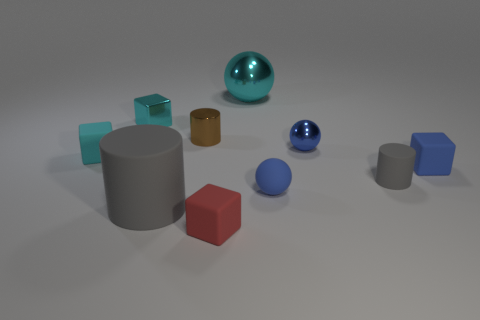Do the tiny metal ball and the rubber ball have the same color?
Keep it short and to the point. Yes. Is there a brown matte thing that has the same shape as the blue metal thing?
Provide a succinct answer. No. What number of objects are either tiny things to the left of the red thing or big purple metallic cylinders?
Give a very brief answer. 3. Are there more tiny red things behind the small red matte block than cyan metal balls in front of the small blue shiny ball?
Offer a very short reply. No. What number of matte things are either small cyan things or blue objects?
Make the answer very short. 3. There is a tiny thing that is the same color as the large matte cylinder; what material is it?
Give a very brief answer. Rubber. Is the number of tiny spheres behind the small gray thing less than the number of cylinders that are to the right of the large gray matte cylinder?
Ensure brevity in your answer.  Yes. What number of things are either big gray objects or small things left of the brown object?
Your answer should be very brief. 3. What is the material of the red object that is the same size as the metal cylinder?
Offer a terse response. Rubber. Is the big cyan thing made of the same material as the tiny brown thing?
Your answer should be compact. Yes. 